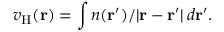<formula> <loc_0><loc_0><loc_500><loc_500>v _ { H } ( r ) = \int n ( r ^ { \prime } ) / | r - r ^ { \prime } | \, d r ^ { \prime } .</formula> 